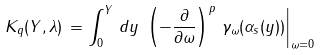Convert formula to latex. <formula><loc_0><loc_0><loc_500><loc_500>K _ { q } ( Y , \lambda ) \, = \int _ { 0 } ^ { Y } \, d y \, \left . \left ( - \frac { \partial } { \partial \omega } \right ) ^ { p } \, \gamma _ { \omega } ( \alpha _ { s } ( y ) ) \right | _ { \omega = 0 }</formula> 